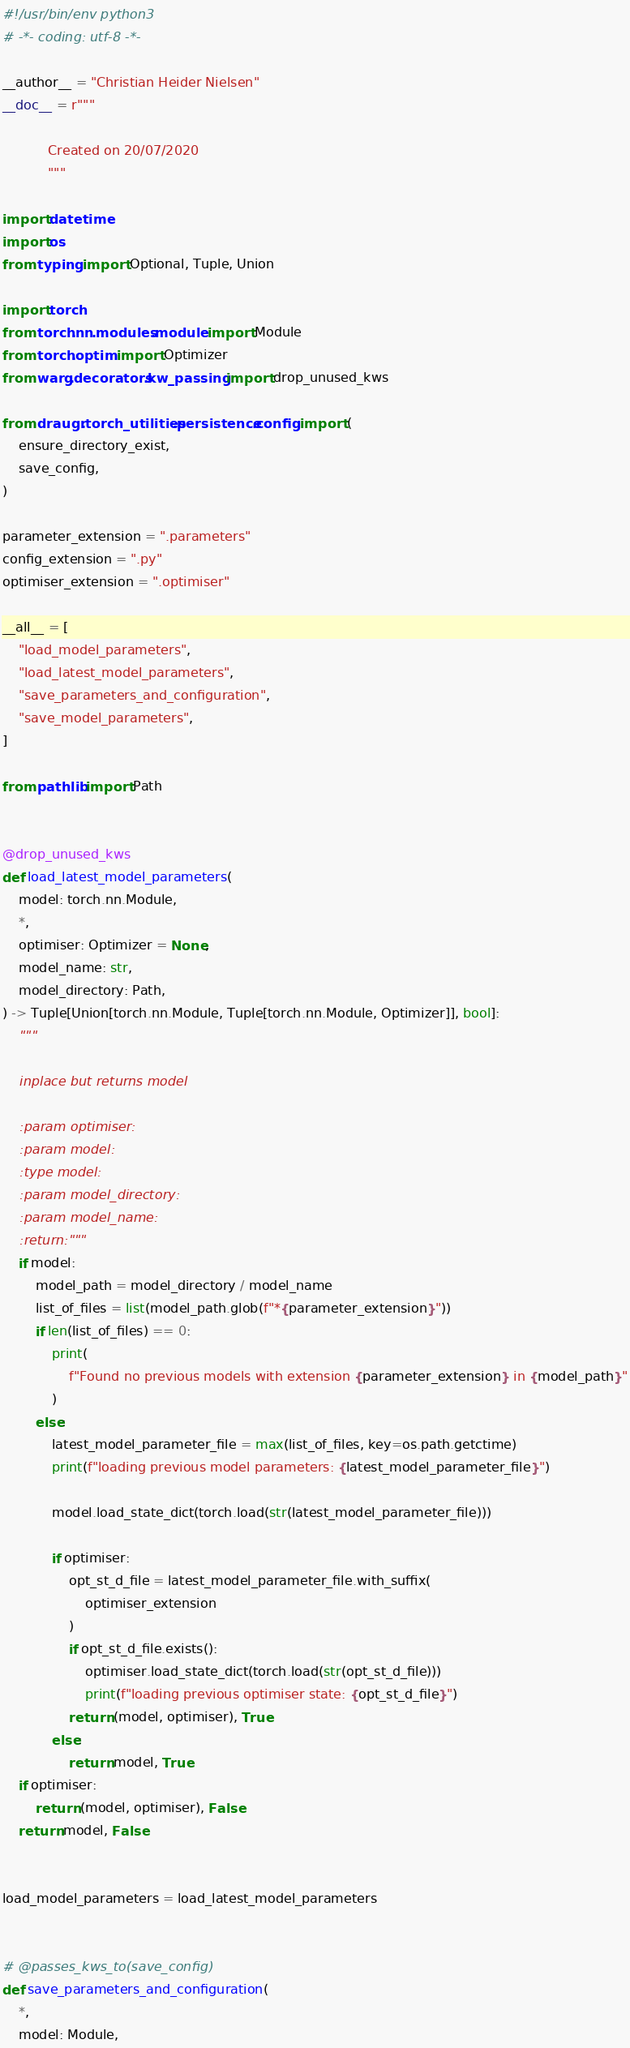Convert code to text. <code><loc_0><loc_0><loc_500><loc_500><_Python_>#!/usr/bin/env python3
# -*- coding: utf-8 -*-

__author__ = "Christian Heider Nielsen"
__doc__ = r"""

           Created on 20/07/2020
           """

import datetime
import os
from typing import Optional, Tuple, Union

import torch
from torch.nn.modules.module import Module
from torch.optim import Optimizer
from warg.decorators.kw_passing import drop_unused_kws

from draugr.torch_utilities.persistence.config import (
    ensure_directory_exist,
    save_config,
)

parameter_extension = ".parameters"
config_extension = ".py"
optimiser_extension = ".optimiser"

__all__ = [
    "load_model_parameters",
    "load_latest_model_parameters",
    "save_parameters_and_configuration",
    "save_model_parameters",
]

from pathlib import Path


@drop_unused_kws
def load_latest_model_parameters(
    model: torch.nn.Module,
    *,
    optimiser: Optimizer = None,
    model_name: str,
    model_directory: Path,
) -> Tuple[Union[torch.nn.Module, Tuple[torch.nn.Module, Optimizer]], bool]:
    """

    inplace but returns model

    :param optimiser:
    :param model:
    :type model:
    :param model_directory:
    :param model_name:
    :return:"""
    if model:
        model_path = model_directory / model_name
        list_of_files = list(model_path.glob(f"*{parameter_extension}"))
        if len(list_of_files) == 0:
            print(
                f"Found no previous models with extension {parameter_extension} in {model_path}"
            )
        else:
            latest_model_parameter_file = max(list_of_files, key=os.path.getctime)
            print(f"loading previous model parameters: {latest_model_parameter_file}")

            model.load_state_dict(torch.load(str(latest_model_parameter_file)))

            if optimiser:
                opt_st_d_file = latest_model_parameter_file.with_suffix(
                    optimiser_extension
                )
                if opt_st_d_file.exists():
                    optimiser.load_state_dict(torch.load(str(opt_st_d_file)))
                    print(f"loading previous optimiser state: {opt_st_d_file}")
                return (model, optimiser), True
            else:
                return model, True
    if optimiser:
        return (model, optimiser), False
    return model, False


load_model_parameters = load_latest_model_parameters


# @passes_kws_to(save_config)
def save_parameters_and_configuration(
    *,
    model: Module,</code> 